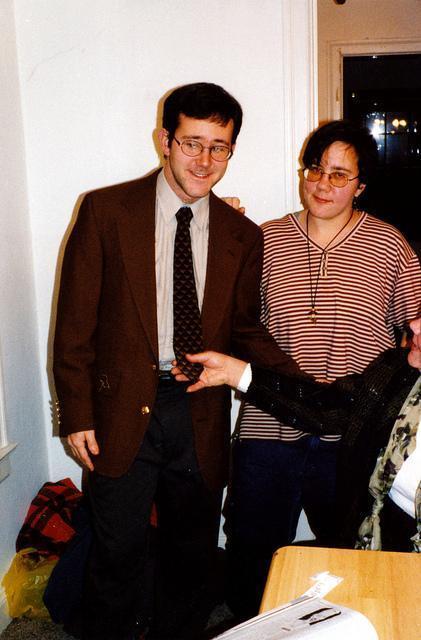How many people are there?
Give a very brief answer. 3. 